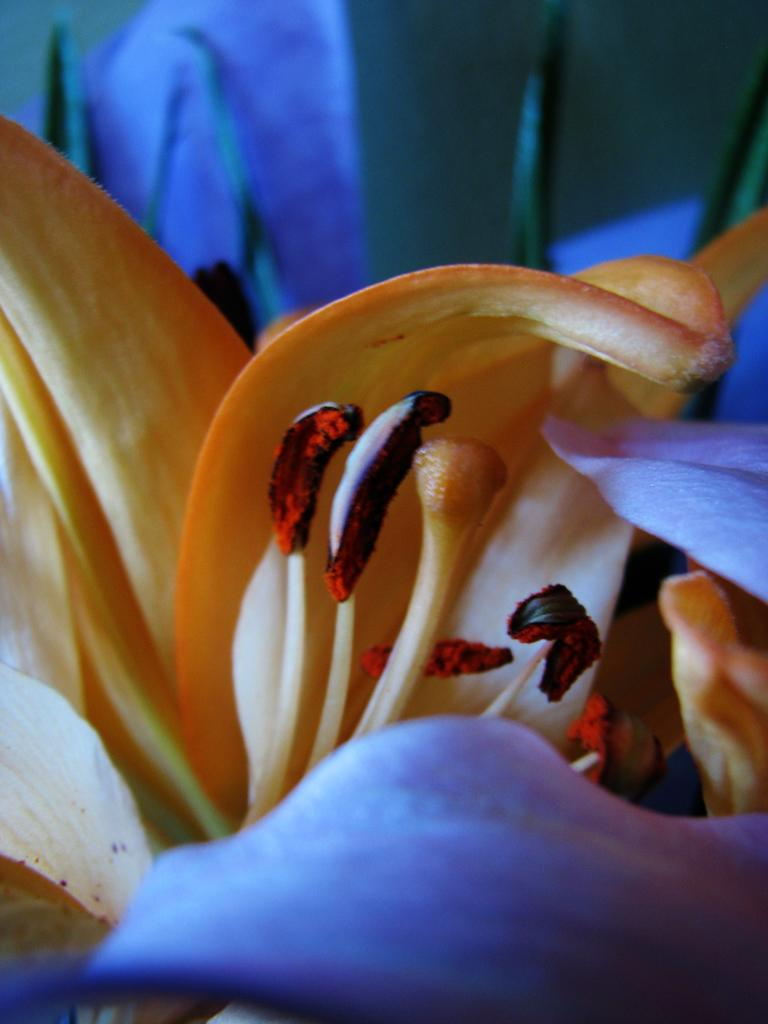What is the main subject of the image? There is a flower in the image. Can you describe the background of the image? The background of the image is not clear. What else can be seen in the image besides the flower? Objects are visible in the background of the image. How does the flower attract the attention of the clouds in the image? There are no clouds present in the image, and therefore no interaction between the flower and clouds can be observed. 